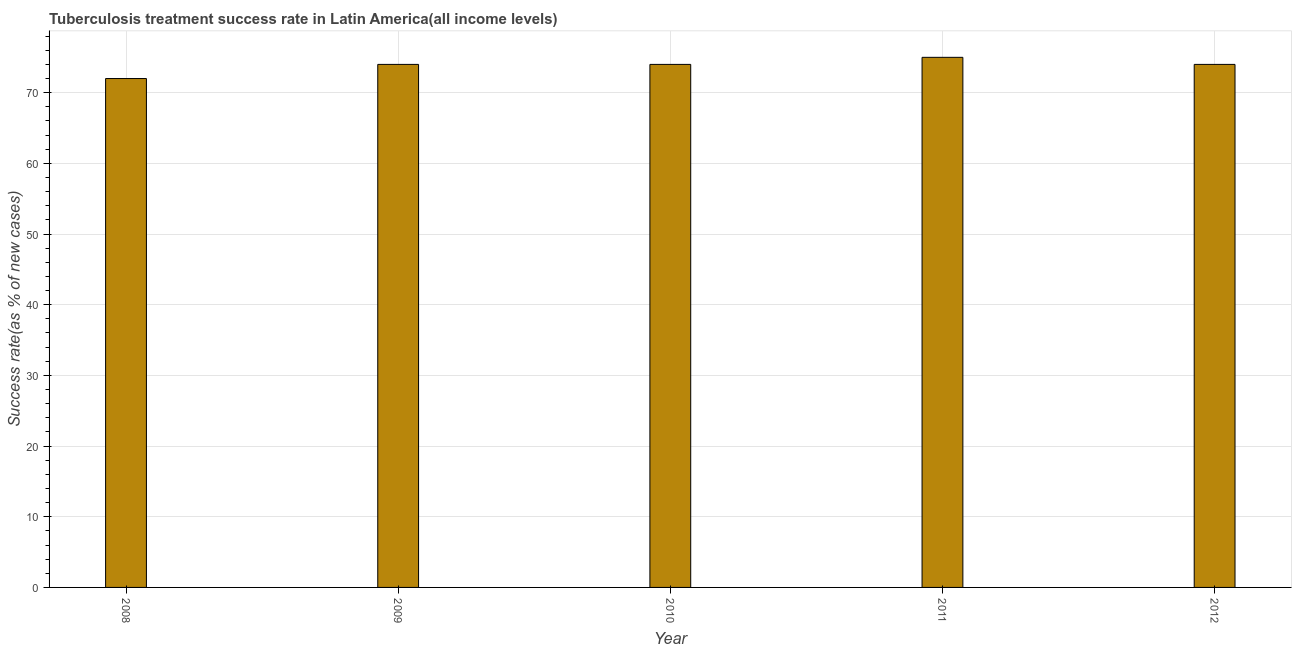Does the graph contain any zero values?
Your answer should be compact. No. What is the title of the graph?
Provide a short and direct response. Tuberculosis treatment success rate in Latin America(all income levels). What is the label or title of the Y-axis?
Provide a short and direct response. Success rate(as % of new cases). Across all years, what is the maximum tuberculosis treatment success rate?
Ensure brevity in your answer.  75. What is the sum of the tuberculosis treatment success rate?
Your answer should be very brief. 369. In how many years, is the tuberculosis treatment success rate greater than 10 %?
Your response must be concise. 5. Do a majority of the years between 2008 and 2011 (inclusive) have tuberculosis treatment success rate greater than 38 %?
Give a very brief answer. Yes. Is the tuberculosis treatment success rate in 2008 less than that in 2012?
Offer a very short reply. Yes. Is the difference between the tuberculosis treatment success rate in 2009 and 2011 greater than the difference between any two years?
Your answer should be compact. No. What is the difference between the highest and the lowest tuberculosis treatment success rate?
Offer a terse response. 3. How many bars are there?
Your response must be concise. 5. What is the difference between two consecutive major ticks on the Y-axis?
Keep it short and to the point. 10. Are the values on the major ticks of Y-axis written in scientific E-notation?
Ensure brevity in your answer.  No. What is the Success rate(as % of new cases) in 2008?
Keep it short and to the point. 72. What is the Success rate(as % of new cases) in 2009?
Your answer should be compact. 74. What is the Success rate(as % of new cases) of 2011?
Give a very brief answer. 75. What is the Success rate(as % of new cases) in 2012?
Offer a terse response. 74. What is the difference between the Success rate(as % of new cases) in 2008 and 2010?
Make the answer very short. -2. What is the difference between the Success rate(as % of new cases) in 2008 and 2012?
Provide a short and direct response. -2. What is the difference between the Success rate(as % of new cases) in 2009 and 2010?
Keep it short and to the point. 0. What is the difference between the Success rate(as % of new cases) in 2009 and 2011?
Ensure brevity in your answer.  -1. What is the ratio of the Success rate(as % of new cases) in 2008 to that in 2009?
Your answer should be compact. 0.97. What is the ratio of the Success rate(as % of new cases) in 2008 to that in 2012?
Your answer should be very brief. 0.97. What is the ratio of the Success rate(as % of new cases) in 2010 to that in 2011?
Your response must be concise. 0.99. 